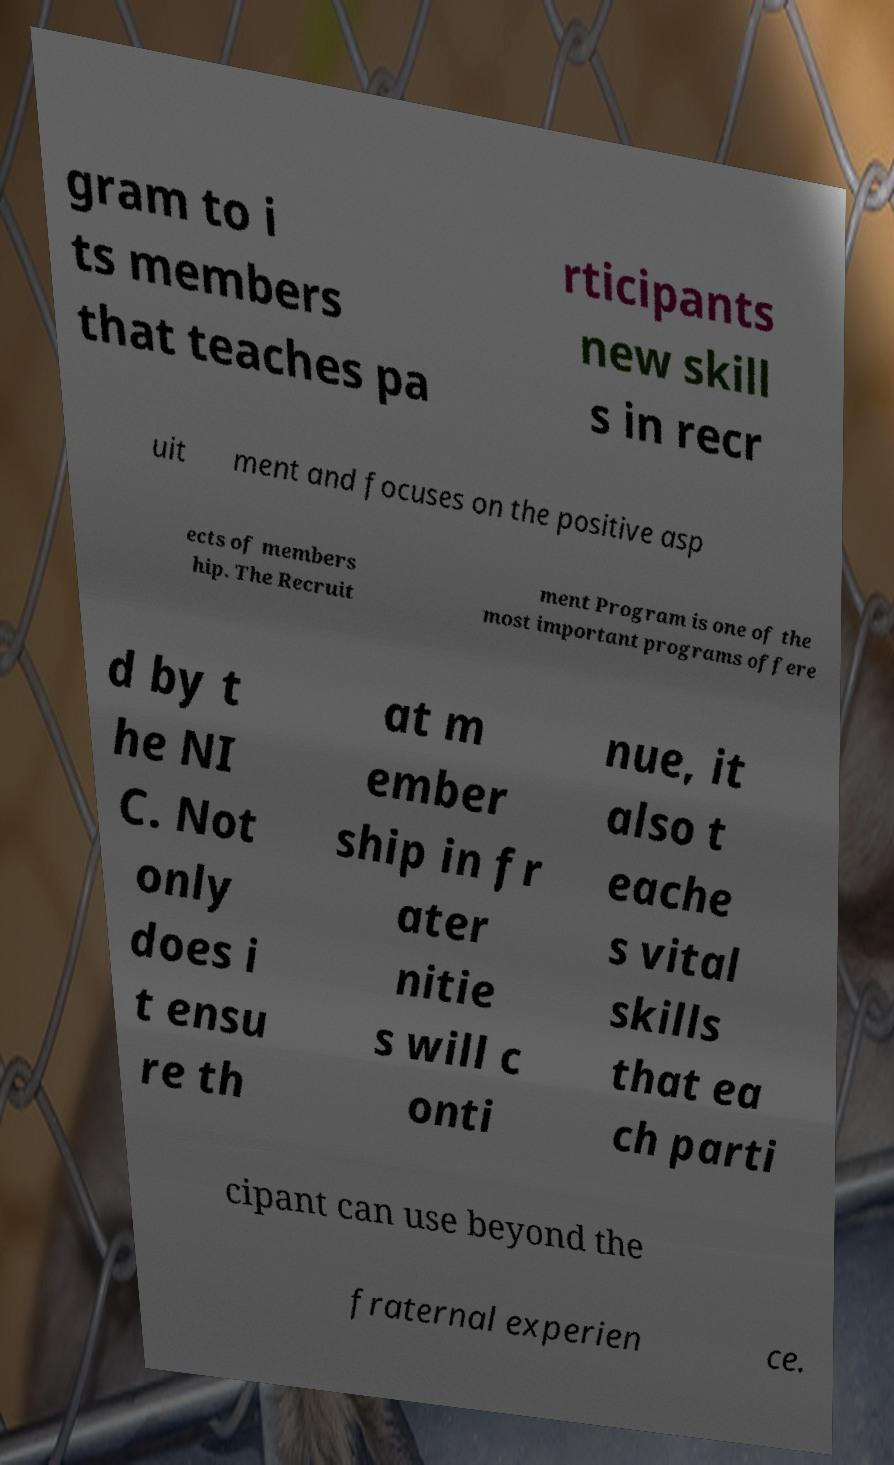There's text embedded in this image that I need extracted. Can you transcribe it verbatim? gram to i ts members that teaches pa rticipants new skill s in recr uit ment and focuses on the positive asp ects of members hip. The Recruit ment Program is one of the most important programs offere d by t he NI C. Not only does i t ensu re th at m ember ship in fr ater nitie s will c onti nue, it also t eache s vital skills that ea ch parti cipant can use beyond the fraternal experien ce. 